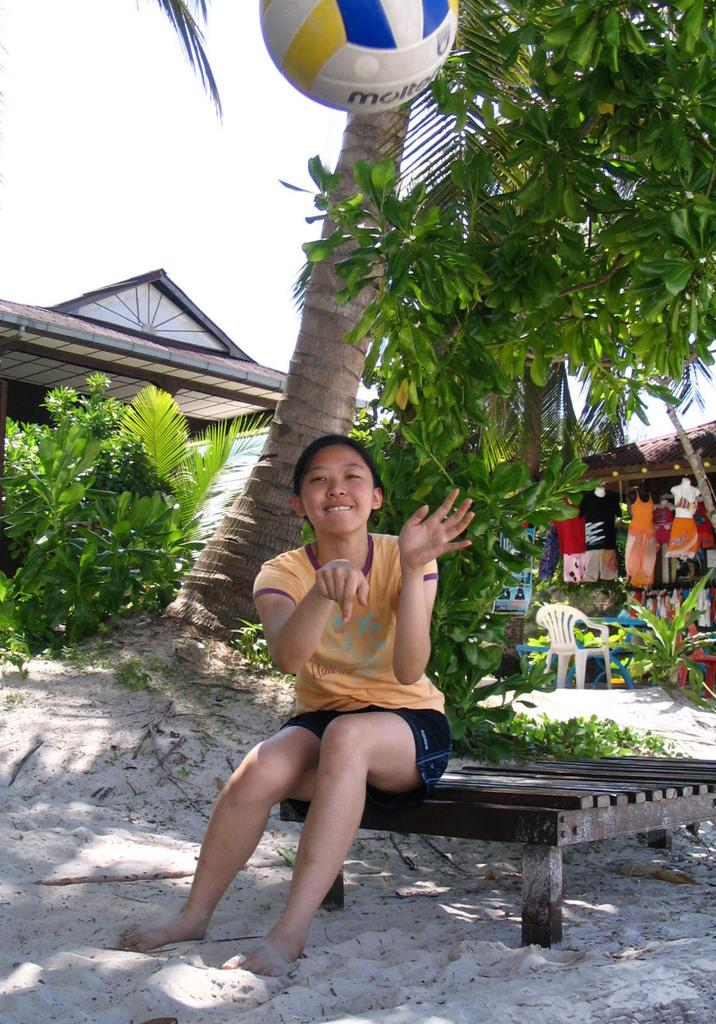What is the person in the image doing? The person is sitting on a wooden bench and throwing a ball. What can be seen behind the person? There are trees and a building behind the person. What items are present in the left corner of the image? Clothes are hanging, and a white chair is present in the left corner of the image. What is the value of the hour shown in the image? There is no clock or indication of time in the image, so it is not possible to determine the value of the hour. 